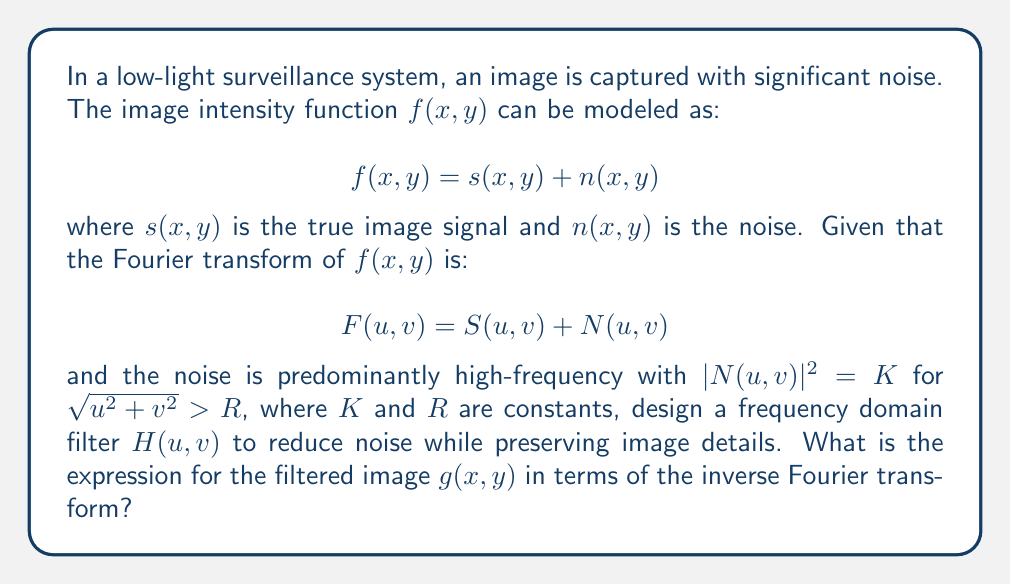What is the answer to this math problem? To enhance image quality and reduce noise in low-light surveillance footage using Fourier transform, we need to design an appropriate filter in the frequency domain. Here's the step-by-step approach:

1) The image in the spatial domain is represented as $f(x,y) = s(x,y) + n(x,y)$, where $s(x,y)$ is the true image and $n(x,y)$ is the noise.

2) In the frequency domain, this becomes $F(u,v) = S(u,v) + N(u,v)$.

3) Given that the noise is predominantly high-frequency with $|N(u,v)|^2 = K$ for $\sqrt{u^2 + v^2} > R$, we can design a low-pass filter to reduce this noise.

4) A suitable filter for this purpose is the Butterworth low-pass filter, defined as:

   $$H(u,v) = \frac{1}{1 + [\sqrt{u^2 + v^2} / R]^{2n}}$$

   where $n$ is the order of the filter and $R$ is the cutoff frequency.

5) To apply this filter in the frequency domain, we multiply $F(u,v)$ by $H(u,v)$:

   $$G(u,v) = H(u,v)F(u,v)$$

6) To get the filtered image in the spatial domain, we need to take the inverse Fourier transform of $G(u,v)$:

   $$g(x,y) = \mathcal{F}^{-1}\{G(u,v)\} = \mathcal{F}^{-1}\{H(u,v)F(u,v)\}$$

Therefore, the expression for the filtered image $g(x,y)$ in terms of the inverse Fourier transform is:

$$g(x,y) = \mathcal{F}^{-1}\{H(u,v)F(u,v)\}$$

This process will reduce high-frequency noise while preserving the important details of the surveillance image, thereby enhancing its quality in low-light conditions.
Answer: $$g(x,y) = \mathcal{F}^{-1}\{H(u,v)F(u,v)\}$$ 